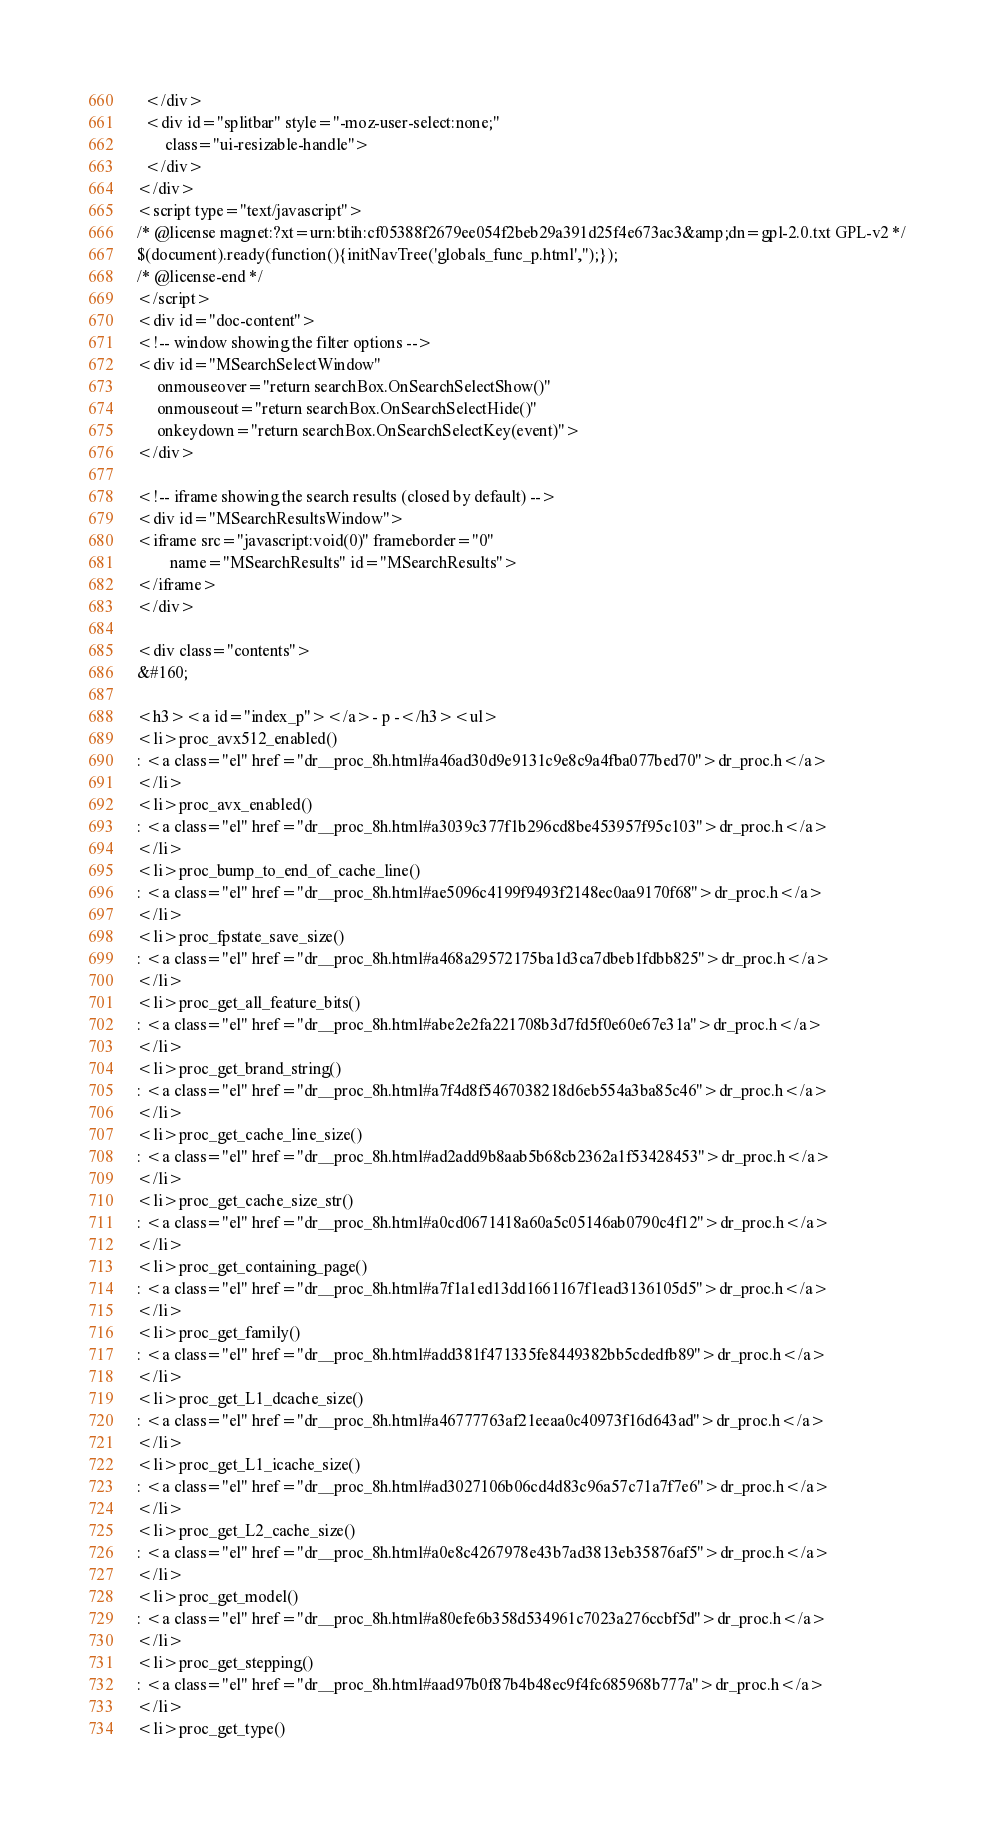<code> <loc_0><loc_0><loc_500><loc_500><_HTML_>  </div>
  <div id="splitbar" style="-moz-user-select:none;" 
       class="ui-resizable-handle">
  </div>
</div>
<script type="text/javascript">
/* @license magnet:?xt=urn:btih:cf05388f2679ee054f2beb29a391d25f4e673ac3&amp;dn=gpl-2.0.txt GPL-v2 */
$(document).ready(function(){initNavTree('globals_func_p.html','');});
/* @license-end */
</script>
<div id="doc-content">
<!-- window showing the filter options -->
<div id="MSearchSelectWindow"
     onmouseover="return searchBox.OnSearchSelectShow()"
     onmouseout="return searchBox.OnSearchSelectHide()"
     onkeydown="return searchBox.OnSearchSelectKey(event)">
</div>

<!-- iframe showing the search results (closed by default) -->
<div id="MSearchResultsWindow">
<iframe src="javascript:void(0)" frameborder="0" 
        name="MSearchResults" id="MSearchResults">
</iframe>
</div>

<div class="contents">
&#160;

<h3><a id="index_p"></a>- p -</h3><ul>
<li>proc_avx512_enabled()
: <a class="el" href="dr__proc_8h.html#a46ad30d9e9131c9e8c9a4fba077bed70">dr_proc.h</a>
</li>
<li>proc_avx_enabled()
: <a class="el" href="dr__proc_8h.html#a3039c377f1b296cd8be453957f95c103">dr_proc.h</a>
</li>
<li>proc_bump_to_end_of_cache_line()
: <a class="el" href="dr__proc_8h.html#ae5096c4199f9493f2148ec0aa9170f68">dr_proc.h</a>
</li>
<li>proc_fpstate_save_size()
: <a class="el" href="dr__proc_8h.html#a468a29572175ba1d3ca7dbeb1fdbb825">dr_proc.h</a>
</li>
<li>proc_get_all_feature_bits()
: <a class="el" href="dr__proc_8h.html#abe2e2fa221708b3d7fd5f0e60e67e31a">dr_proc.h</a>
</li>
<li>proc_get_brand_string()
: <a class="el" href="dr__proc_8h.html#a7f4d8f5467038218d6eb554a3ba85c46">dr_proc.h</a>
</li>
<li>proc_get_cache_line_size()
: <a class="el" href="dr__proc_8h.html#ad2add9b8aab5b68cb2362a1f53428453">dr_proc.h</a>
</li>
<li>proc_get_cache_size_str()
: <a class="el" href="dr__proc_8h.html#a0cd0671418a60a5c05146ab0790c4f12">dr_proc.h</a>
</li>
<li>proc_get_containing_page()
: <a class="el" href="dr__proc_8h.html#a7f1a1ed13dd1661167f1ead3136105d5">dr_proc.h</a>
</li>
<li>proc_get_family()
: <a class="el" href="dr__proc_8h.html#add381f471335fe8449382bb5cdedfb89">dr_proc.h</a>
</li>
<li>proc_get_L1_dcache_size()
: <a class="el" href="dr__proc_8h.html#a46777763af21eeaa0c40973f16d643ad">dr_proc.h</a>
</li>
<li>proc_get_L1_icache_size()
: <a class="el" href="dr__proc_8h.html#ad3027106b06cd4d83c96a57c71a7f7e6">dr_proc.h</a>
</li>
<li>proc_get_L2_cache_size()
: <a class="el" href="dr__proc_8h.html#a0e8c4267978e43b7ad3813eb35876af5">dr_proc.h</a>
</li>
<li>proc_get_model()
: <a class="el" href="dr__proc_8h.html#a80efe6b358d534961c7023a276ccbf5d">dr_proc.h</a>
</li>
<li>proc_get_stepping()
: <a class="el" href="dr__proc_8h.html#aad97b0f87b4b48ec9f4fc685968b777a">dr_proc.h</a>
</li>
<li>proc_get_type()</code> 